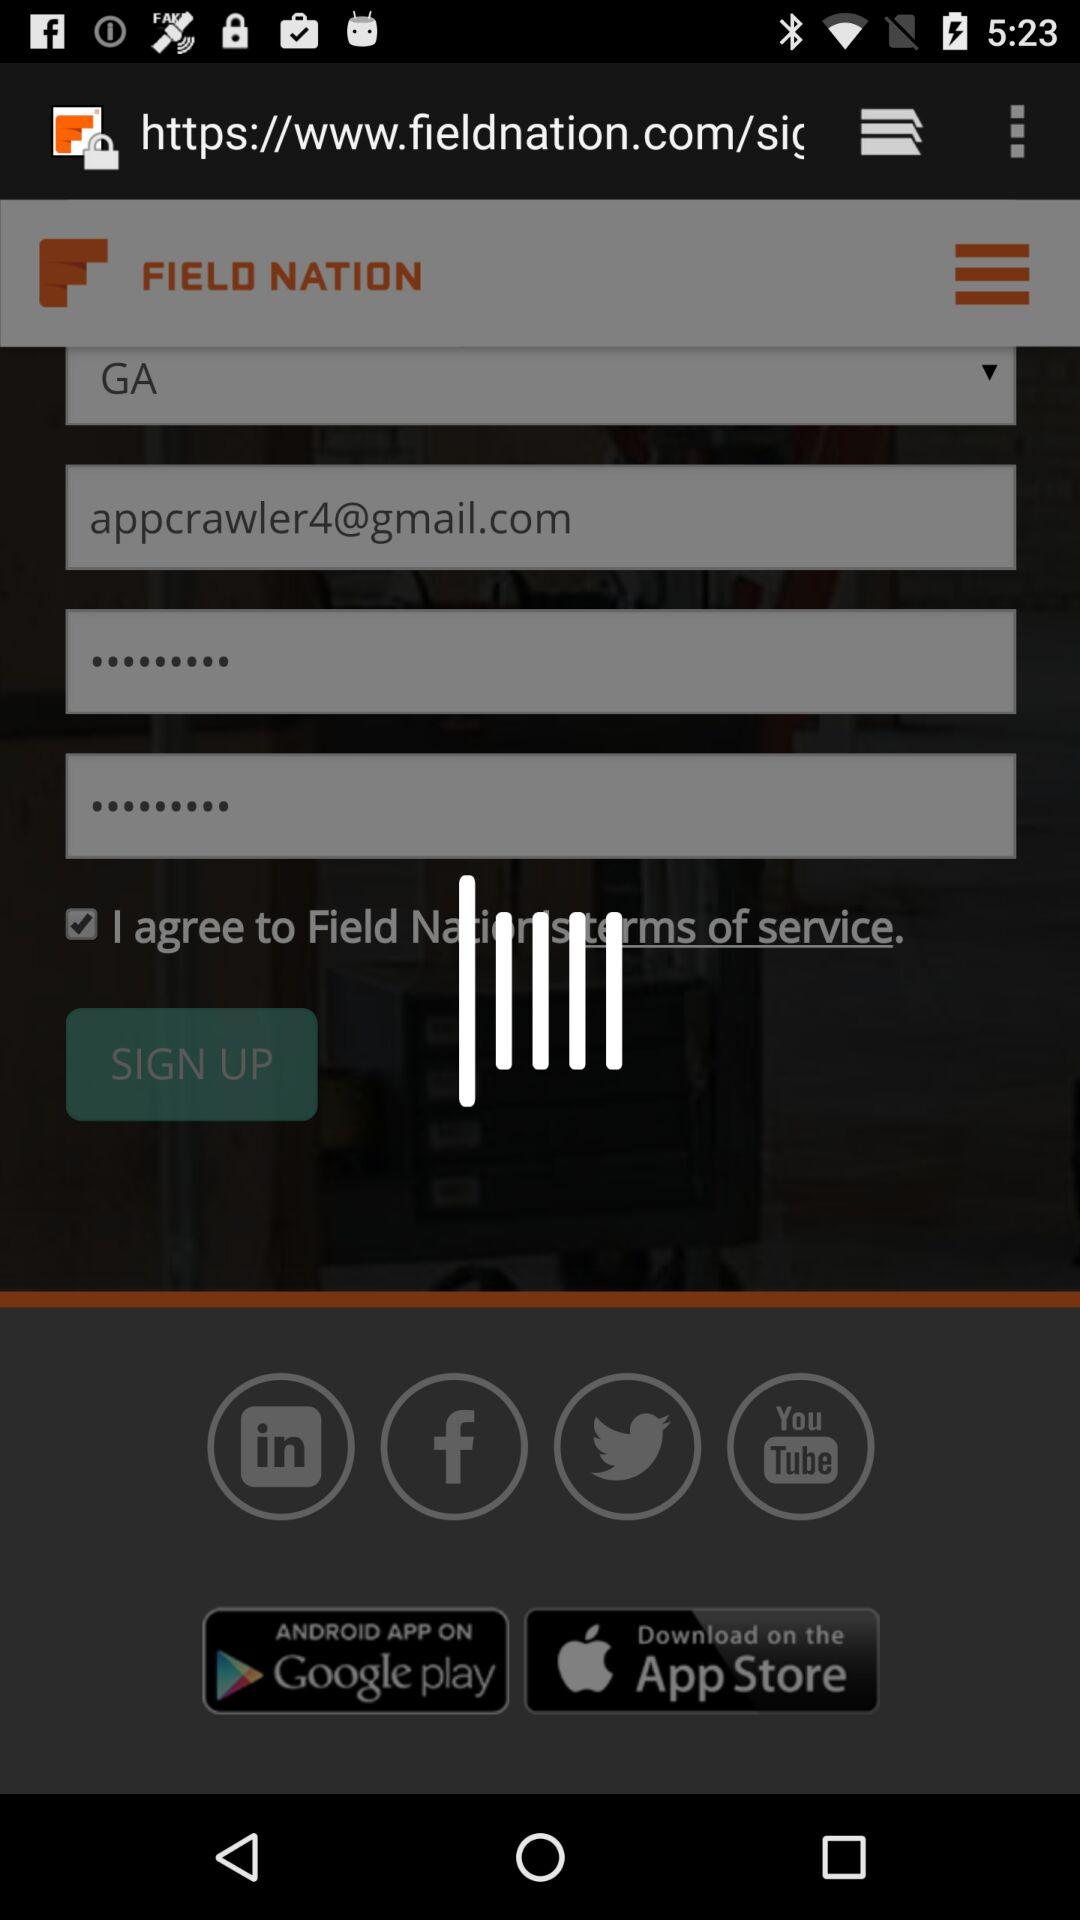How many text inputs are on the sign up page?
Answer the question using a single word or phrase. 4 